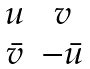Convert formula to latex. <formula><loc_0><loc_0><loc_500><loc_500>\begin{matrix} u & v \\ \bar { v } & - \bar { u } \\ \end{matrix}</formula> 